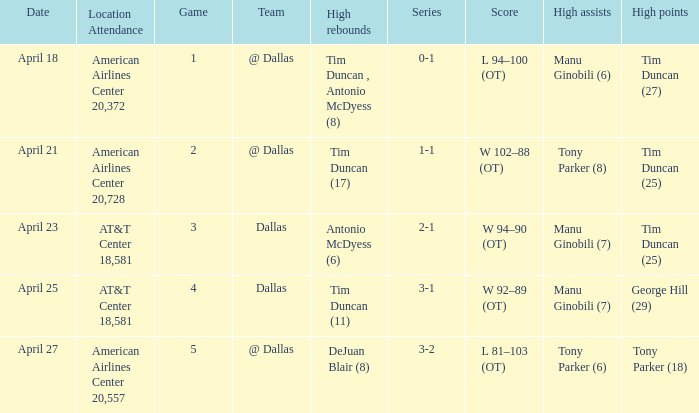When 0-1 is the series who has the highest amount of assists? Manu Ginobili (6). 